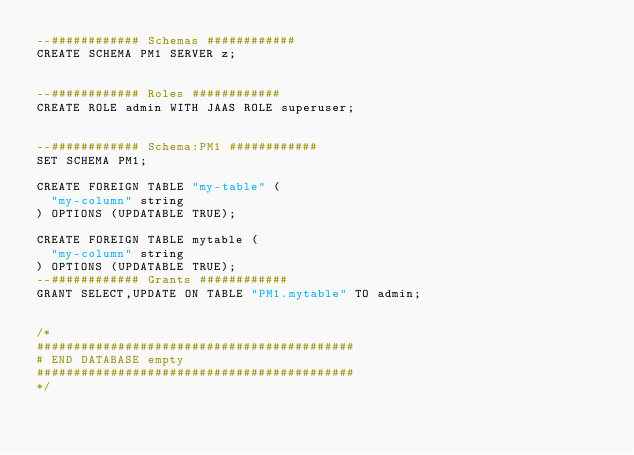<code> <loc_0><loc_0><loc_500><loc_500><_SQL_>--############ Schemas ############
CREATE SCHEMA PM1 SERVER z;


--############ Roles ############
CREATE ROLE admin WITH JAAS ROLE superuser;


--############ Schema:PM1 ############
SET SCHEMA PM1;

CREATE FOREIGN TABLE "my-table" (
	"my-column" string
) OPTIONS (UPDATABLE TRUE);

CREATE FOREIGN TABLE mytable (
	"my-column" string
) OPTIONS (UPDATABLE TRUE);
--############ Grants ############
GRANT SELECT,UPDATE ON TABLE "PM1.mytable" TO admin;


/*
###########################################
# END DATABASE empty
###########################################
*/

</code> 